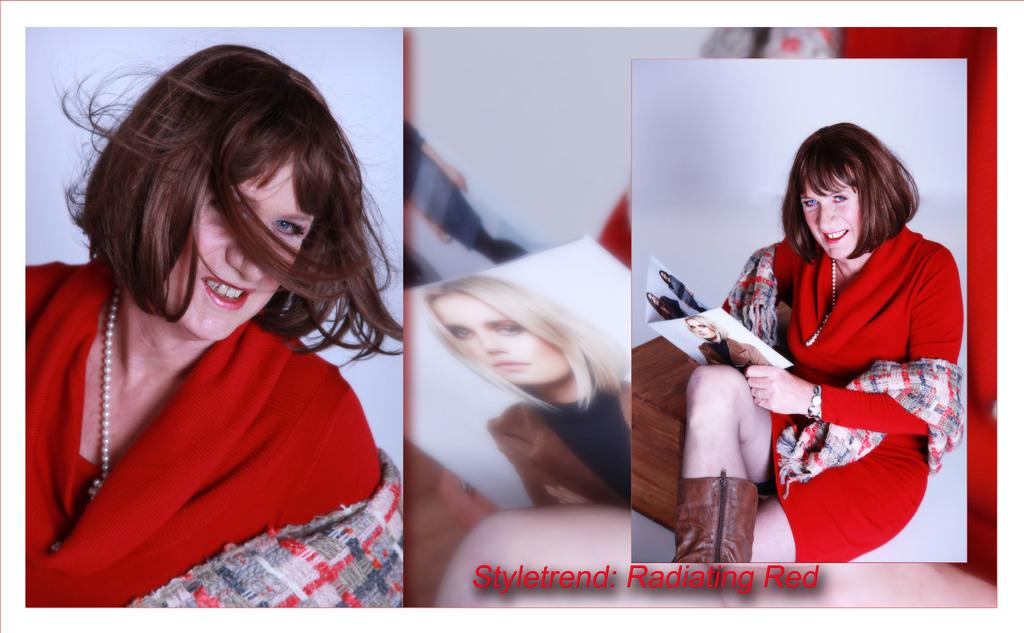What type of artwork is shown in the image? The image is a collage of pictures. Can you describe one of the pictures in the collage? There is a picture of a woman sitting, and she is holding a book. What is the woman wearing in the picture? The woman is wearing a red color dress. What type of science experiment is the woman conducting in the picture? There is no science experiment or any indication of scientific activity in the image. The woman is simply sitting and holding a book. 